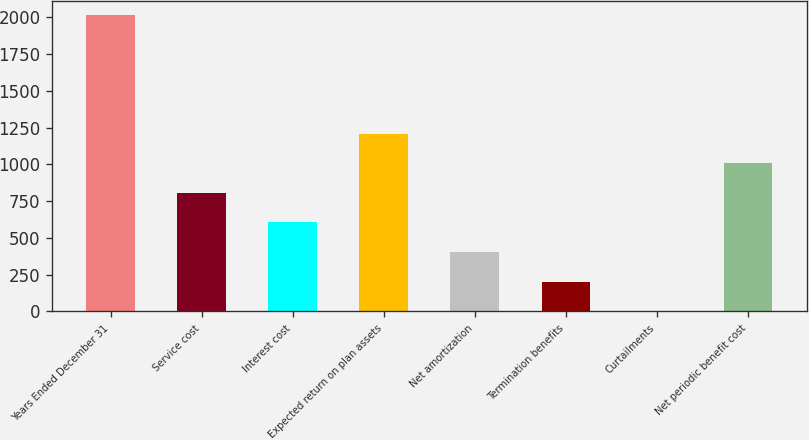Convert chart to OTSL. <chart><loc_0><loc_0><loc_500><loc_500><bar_chart><fcel>Years Ended December 31<fcel>Service cost<fcel>Interest cost<fcel>Expected return on plan assets<fcel>Net amortization<fcel>Termination benefits<fcel>Curtailments<fcel>Net periodic benefit cost<nl><fcel>2013<fcel>805.8<fcel>604.6<fcel>1208.2<fcel>403.4<fcel>202.2<fcel>1<fcel>1007<nl></chart> 